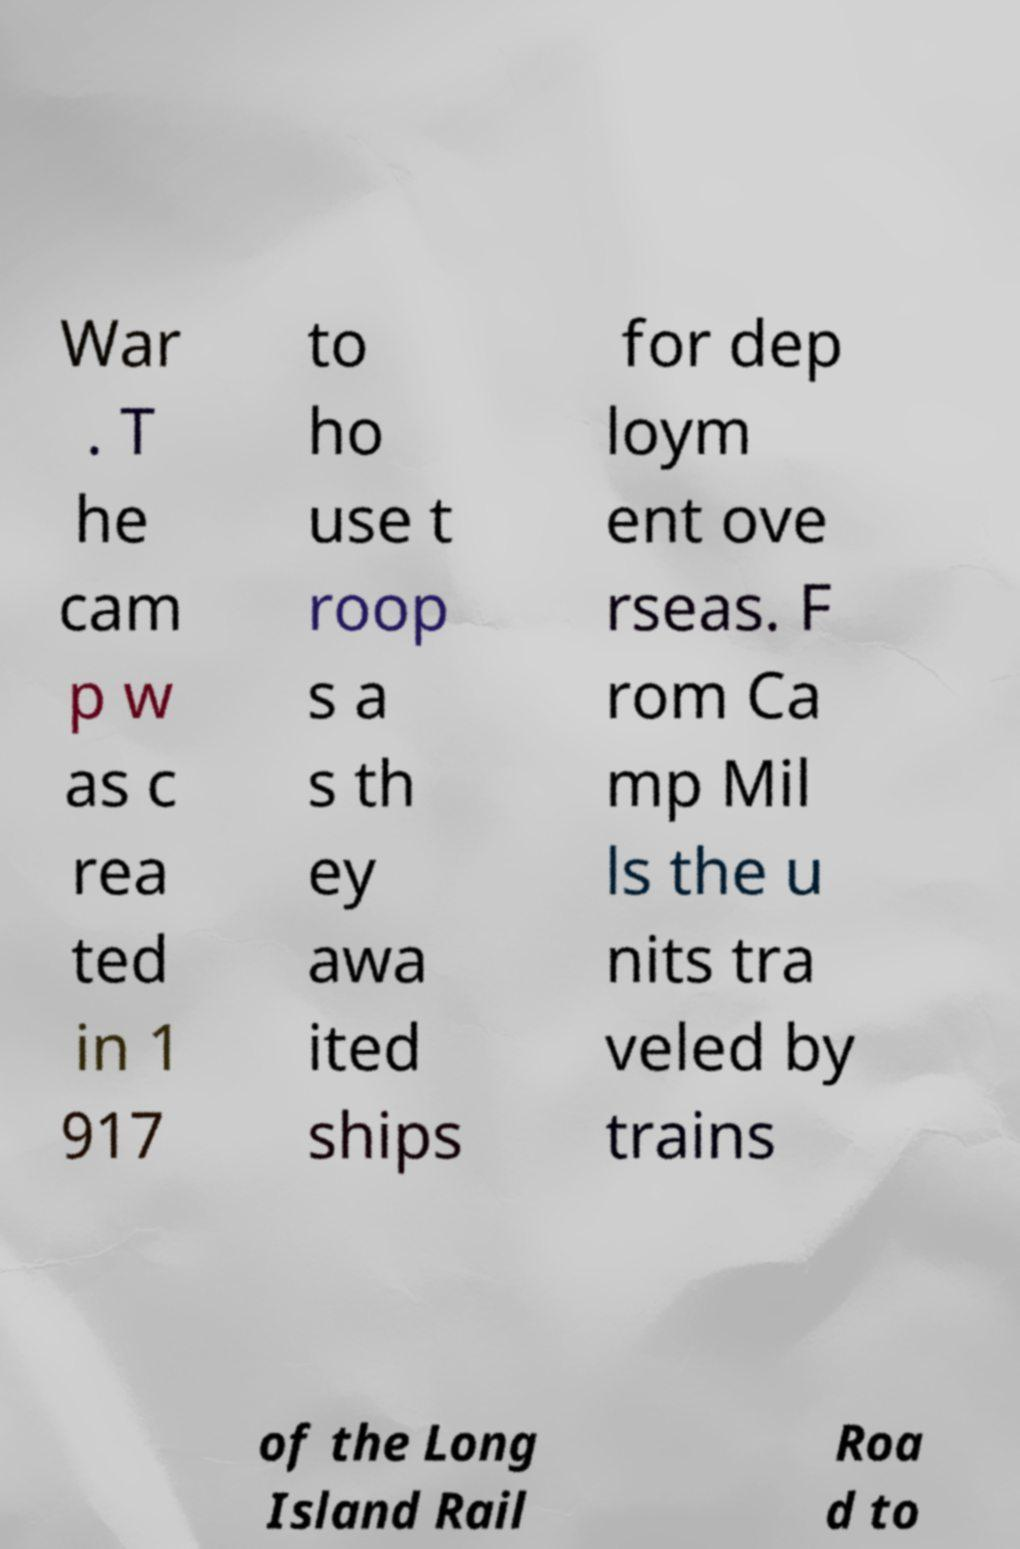Please identify and transcribe the text found in this image. War . T he cam p w as c rea ted in 1 917 to ho use t roop s a s th ey awa ited ships for dep loym ent ove rseas. F rom Ca mp Mil ls the u nits tra veled by trains of the Long Island Rail Roa d to 